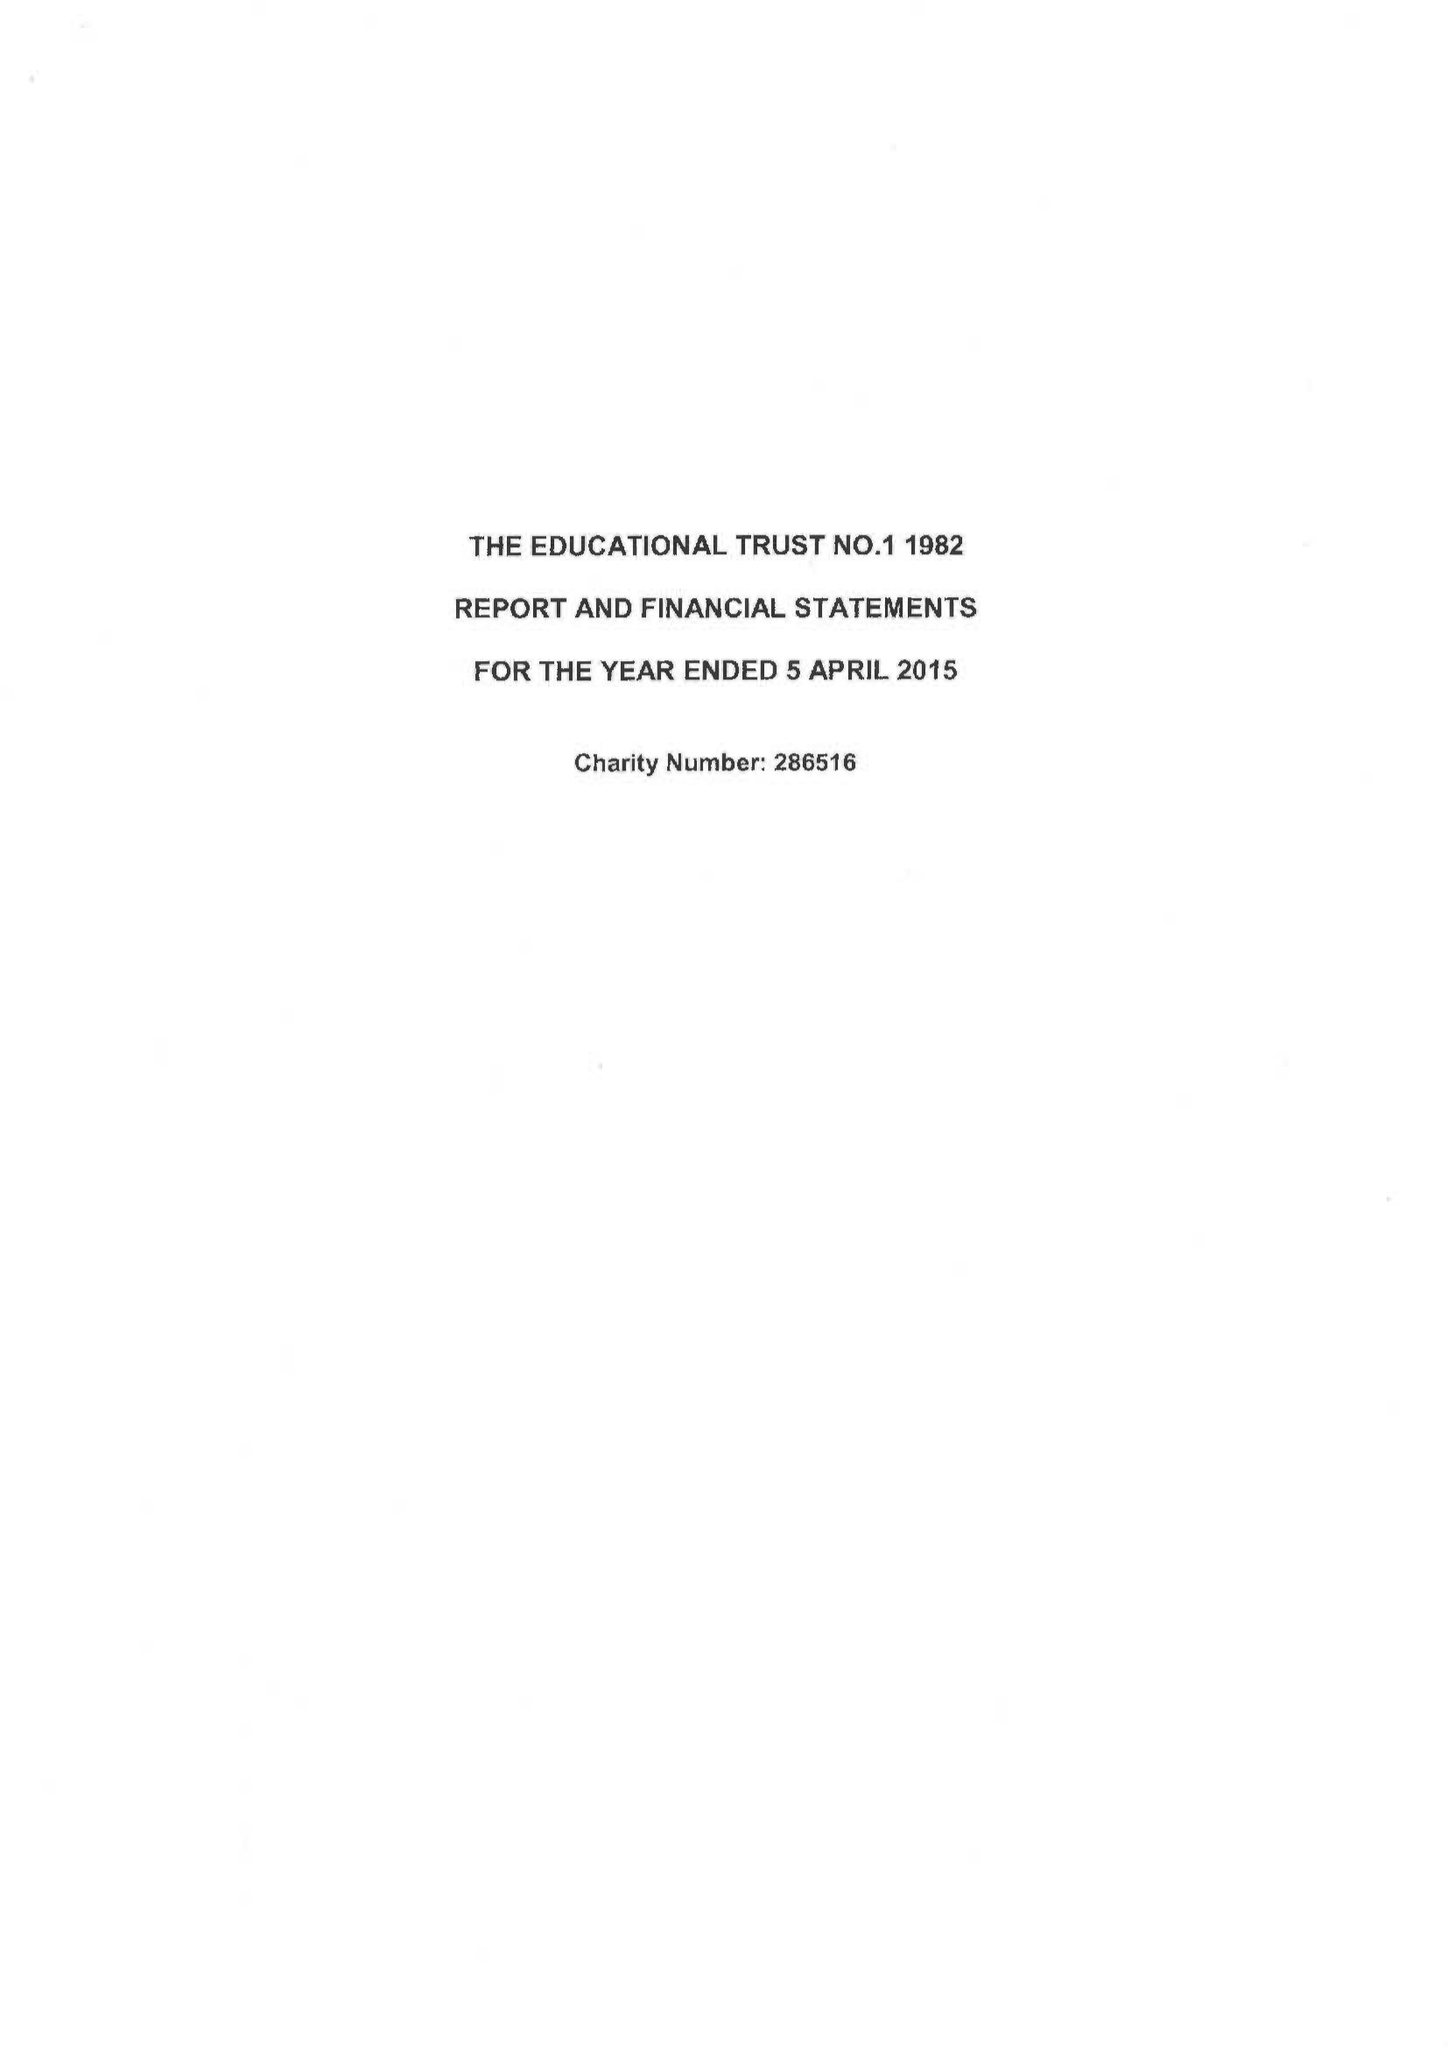What is the value for the address__post_town?
Answer the question using a single word or phrase. FAREHAM 